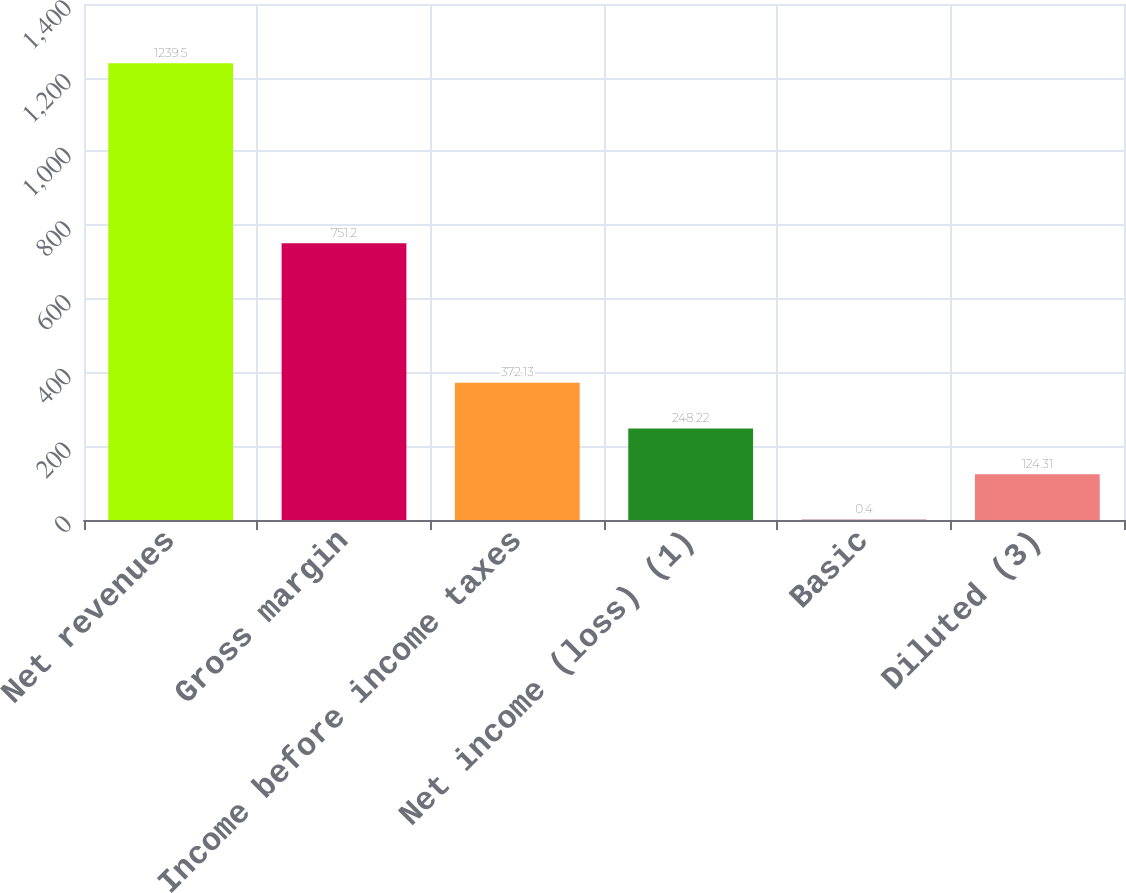<chart> <loc_0><loc_0><loc_500><loc_500><bar_chart><fcel>Net revenues<fcel>Gross margin<fcel>Income before income taxes<fcel>Net income (loss) (1)<fcel>Basic<fcel>Diluted (3)<nl><fcel>1239.5<fcel>751.2<fcel>372.13<fcel>248.22<fcel>0.4<fcel>124.31<nl></chart> 